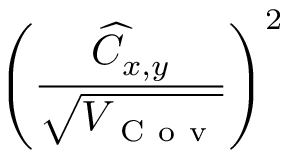Convert formula to latex. <formula><loc_0><loc_0><loc_500><loc_500>\left ( \frac { \widehat { C } _ { x , y } } { \sqrt { V _ { C o v } } } \right ) ^ { 2 }</formula> 